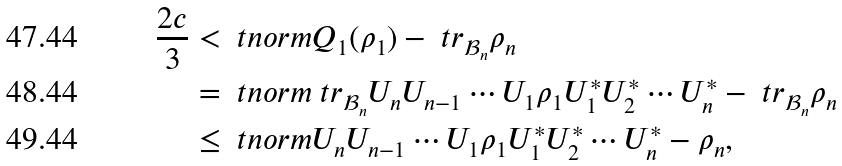Convert formula to latex. <formula><loc_0><loc_0><loc_500><loc_500>\frac { 2 c } { 3 } & < \ t n o r m { Q _ { 1 } ( \rho _ { 1 } ) - \ t r _ { \mathcal { B } _ { n } } \rho _ { n } } \\ & = \ t n o r m { \ t r _ { \mathcal { B } _ { n } } U _ { n } U _ { n - 1 } \cdots U _ { 1 } \rho _ { 1 } U _ { 1 } ^ { * } U _ { 2 } ^ { * } \cdots U _ { n } ^ { * } - \ t r _ { \mathcal { B } _ { n } } \rho _ { n } } \\ & \leq \ t n o r m { U _ { n } U _ { n - 1 } \cdots U _ { 1 } \rho _ { 1 } U _ { 1 } ^ { * } U _ { 2 } ^ { * } \cdots U _ { n } ^ { * } - \rho _ { n } } ,</formula> 